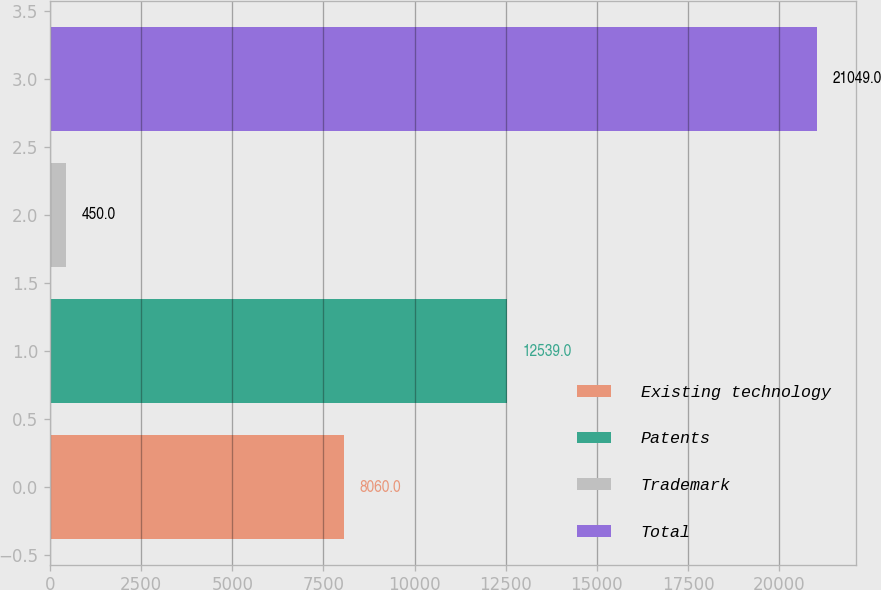<chart> <loc_0><loc_0><loc_500><loc_500><bar_chart><fcel>Existing technology<fcel>Patents<fcel>Trademark<fcel>Total<nl><fcel>8060<fcel>12539<fcel>450<fcel>21049<nl></chart> 